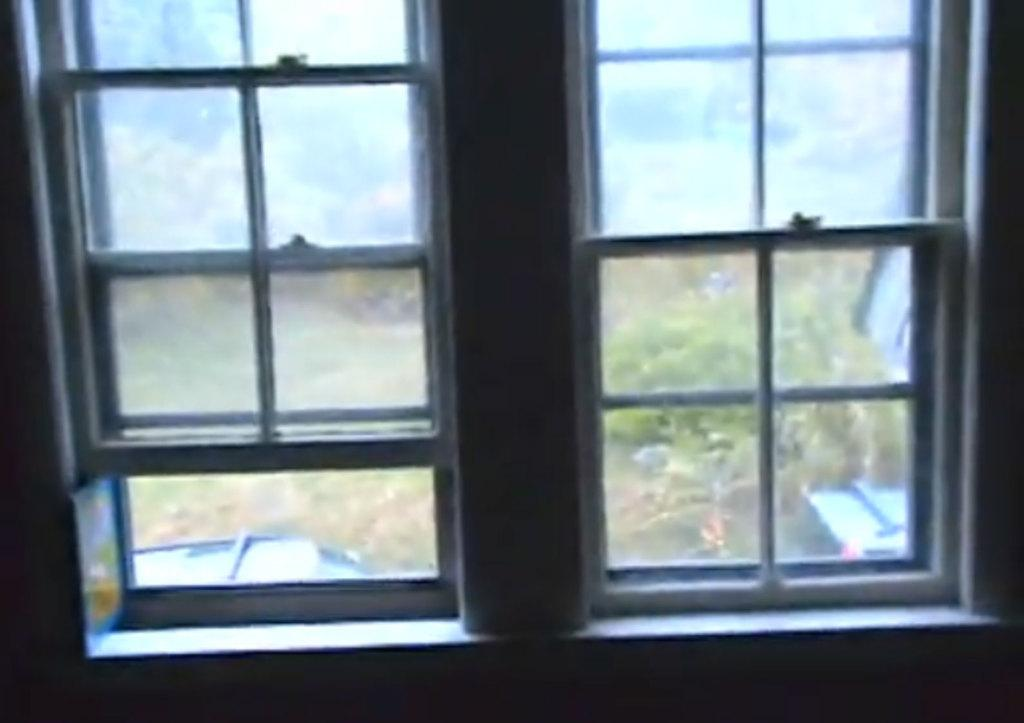What is present in the image that provides a view of the outside? There is a window in the image that provides a view of the outside. What can be seen through the window? Many plants are visible outside the window. What type of ring can be seen on the plants outside the window? There is no ring present on the plants outside the window in the image. 